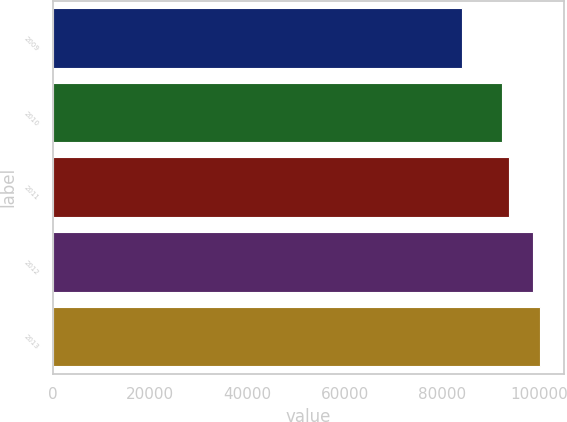Convert chart to OTSL. <chart><loc_0><loc_0><loc_500><loc_500><bar_chart><fcel>2009<fcel>2010<fcel>2011<fcel>2012<fcel>2013<nl><fcel>84050<fcel>92300<fcel>93770<fcel>98650<fcel>100120<nl></chart> 